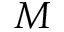Convert formula to latex. <formula><loc_0><loc_0><loc_500><loc_500>M</formula> 